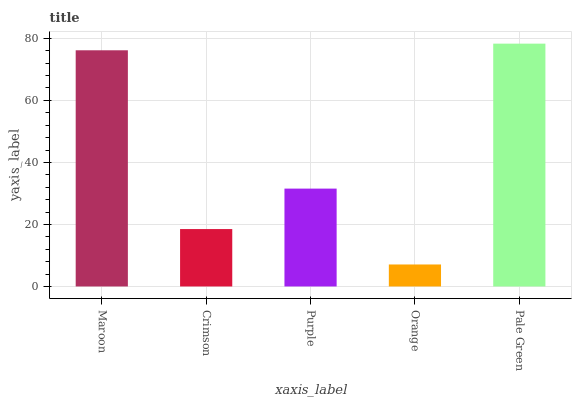Is Orange the minimum?
Answer yes or no. Yes. Is Pale Green the maximum?
Answer yes or no. Yes. Is Crimson the minimum?
Answer yes or no. No. Is Crimson the maximum?
Answer yes or no. No. Is Maroon greater than Crimson?
Answer yes or no. Yes. Is Crimson less than Maroon?
Answer yes or no. Yes. Is Crimson greater than Maroon?
Answer yes or no. No. Is Maroon less than Crimson?
Answer yes or no. No. Is Purple the high median?
Answer yes or no. Yes. Is Purple the low median?
Answer yes or no. Yes. Is Orange the high median?
Answer yes or no. No. Is Maroon the low median?
Answer yes or no. No. 